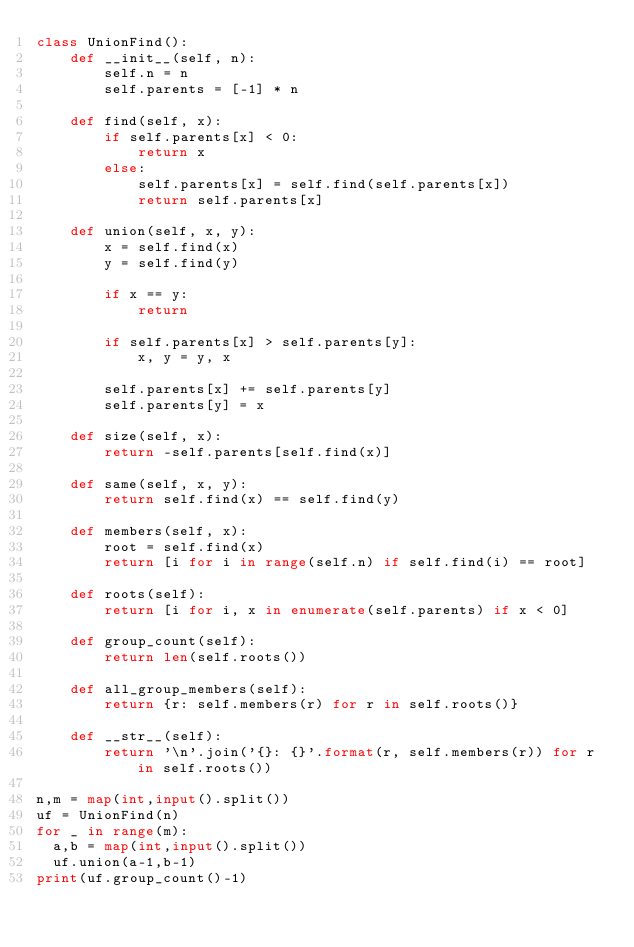Convert code to text. <code><loc_0><loc_0><loc_500><loc_500><_Python_>class UnionFind():
    def __init__(self, n):
        self.n = n
        self.parents = [-1] * n

    def find(self, x):
        if self.parents[x] < 0:
            return x
        else:
            self.parents[x] = self.find(self.parents[x])
            return self.parents[x]

    def union(self, x, y):
        x = self.find(x)
        y = self.find(y)

        if x == y:
            return

        if self.parents[x] > self.parents[y]:
            x, y = y, x

        self.parents[x] += self.parents[y]
        self.parents[y] = x

    def size(self, x):
        return -self.parents[self.find(x)]

    def same(self, x, y):
        return self.find(x) == self.find(y)

    def members(self, x):
        root = self.find(x)
        return [i for i in range(self.n) if self.find(i) == root]

    def roots(self):
        return [i for i, x in enumerate(self.parents) if x < 0]

    def group_count(self):
        return len(self.roots())

    def all_group_members(self):
        return {r: self.members(r) for r in self.roots()}

    def __str__(self):
        return '\n'.join('{}: {}'.format(r, self.members(r)) for r in self.roots())

n,m = map(int,input().split())
uf = UnionFind(n)
for _ in range(m):
  a,b = map(int,input().split())
  uf.union(a-1,b-1)
print(uf.group_count()-1)</code> 